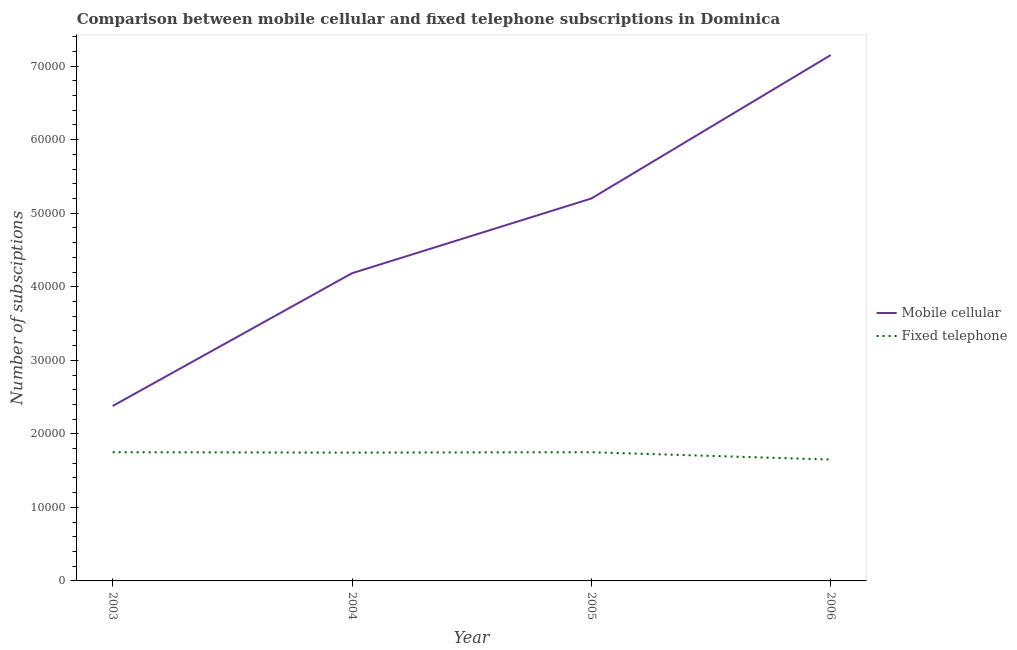What is the number of mobile cellular subscriptions in 2006?
Your answer should be compact. 7.15e+04. Across all years, what is the maximum number of mobile cellular subscriptions?
Keep it short and to the point. 7.15e+04. Across all years, what is the minimum number of fixed telephone subscriptions?
Your answer should be very brief. 1.65e+04. What is the total number of fixed telephone subscriptions in the graph?
Your answer should be very brief. 6.90e+04. What is the difference between the number of fixed telephone subscriptions in 2004 and that in 2005?
Your response must be concise. -50. What is the difference between the number of mobile cellular subscriptions in 2003 and the number of fixed telephone subscriptions in 2005?
Your answer should be very brief. 6286. What is the average number of mobile cellular subscriptions per year?
Offer a very short reply. 4.73e+04. In the year 2005, what is the difference between the number of mobile cellular subscriptions and number of fixed telephone subscriptions?
Provide a short and direct response. 3.45e+04. In how many years, is the number of fixed telephone subscriptions greater than 70000?
Offer a very short reply. 0. What is the difference between the highest and the second highest number of fixed telephone subscriptions?
Provide a succinct answer. 0. What is the difference between the highest and the lowest number of mobile cellular subscriptions?
Offer a very short reply. 4.77e+04. In how many years, is the number of mobile cellular subscriptions greater than the average number of mobile cellular subscriptions taken over all years?
Give a very brief answer. 2. Is the number of fixed telephone subscriptions strictly greater than the number of mobile cellular subscriptions over the years?
Keep it short and to the point. No. How many lines are there?
Your response must be concise. 2. Does the graph contain any zero values?
Ensure brevity in your answer.  No. Does the graph contain grids?
Your answer should be compact. No. How many legend labels are there?
Provide a short and direct response. 2. How are the legend labels stacked?
Offer a terse response. Vertical. What is the title of the graph?
Your answer should be very brief. Comparison between mobile cellular and fixed telephone subscriptions in Dominica. What is the label or title of the Y-axis?
Ensure brevity in your answer.  Number of subsciptions. What is the Number of subsciptions of Mobile cellular in 2003?
Your answer should be very brief. 2.38e+04. What is the Number of subsciptions of Fixed telephone in 2003?
Offer a terse response. 1.75e+04. What is the Number of subsciptions of Mobile cellular in 2004?
Make the answer very short. 4.18e+04. What is the Number of subsciptions of Fixed telephone in 2004?
Give a very brief answer. 1.74e+04. What is the Number of subsciptions in Mobile cellular in 2005?
Your response must be concise. 5.20e+04. What is the Number of subsciptions in Fixed telephone in 2005?
Your response must be concise. 1.75e+04. What is the Number of subsciptions of Mobile cellular in 2006?
Offer a very short reply. 7.15e+04. What is the Number of subsciptions in Fixed telephone in 2006?
Offer a very short reply. 1.65e+04. Across all years, what is the maximum Number of subsciptions of Mobile cellular?
Provide a short and direct response. 7.15e+04. Across all years, what is the maximum Number of subsciptions in Fixed telephone?
Your response must be concise. 1.75e+04. Across all years, what is the minimum Number of subsciptions of Mobile cellular?
Your response must be concise. 2.38e+04. Across all years, what is the minimum Number of subsciptions of Fixed telephone?
Keep it short and to the point. 1.65e+04. What is the total Number of subsciptions of Mobile cellular in the graph?
Ensure brevity in your answer.  1.89e+05. What is the total Number of subsciptions of Fixed telephone in the graph?
Give a very brief answer. 6.90e+04. What is the difference between the Number of subsciptions in Mobile cellular in 2003 and that in 2004?
Ensure brevity in your answer.  -1.81e+04. What is the difference between the Number of subsciptions in Fixed telephone in 2003 and that in 2004?
Your response must be concise. 50. What is the difference between the Number of subsciptions in Mobile cellular in 2003 and that in 2005?
Make the answer very short. -2.82e+04. What is the difference between the Number of subsciptions of Mobile cellular in 2003 and that in 2006?
Keep it short and to the point. -4.77e+04. What is the difference between the Number of subsciptions of Fixed telephone in 2003 and that in 2006?
Give a very brief answer. 1000. What is the difference between the Number of subsciptions of Mobile cellular in 2004 and that in 2005?
Offer a very short reply. -1.02e+04. What is the difference between the Number of subsciptions in Mobile cellular in 2004 and that in 2006?
Provide a succinct answer. -2.97e+04. What is the difference between the Number of subsciptions in Fixed telephone in 2004 and that in 2006?
Give a very brief answer. 950. What is the difference between the Number of subsciptions of Mobile cellular in 2005 and that in 2006?
Offer a very short reply. -1.95e+04. What is the difference between the Number of subsciptions of Mobile cellular in 2003 and the Number of subsciptions of Fixed telephone in 2004?
Provide a short and direct response. 6336. What is the difference between the Number of subsciptions in Mobile cellular in 2003 and the Number of subsciptions in Fixed telephone in 2005?
Ensure brevity in your answer.  6286. What is the difference between the Number of subsciptions of Mobile cellular in 2003 and the Number of subsciptions of Fixed telephone in 2006?
Ensure brevity in your answer.  7286. What is the difference between the Number of subsciptions of Mobile cellular in 2004 and the Number of subsciptions of Fixed telephone in 2005?
Make the answer very short. 2.43e+04. What is the difference between the Number of subsciptions of Mobile cellular in 2004 and the Number of subsciptions of Fixed telephone in 2006?
Keep it short and to the point. 2.53e+04. What is the difference between the Number of subsciptions of Mobile cellular in 2005 and the Number of subsciptions of Fixed telephone in 2006?
Your answer should be compact. 3.55e+04. What is the average Number of subsciptions in Mobile cellular per year?
Offer a very short reply. 4.73e+04. What is the average Number of subsciptions of Fixed telephone per year?
Offer a very short reply. 1.72e+04. In the year 2003, what is the difference between the Number of subsciptions of Mobile cellular and Number of subsciptions of Fixed telephone?
Your response must be concise. 6286. In the year 2004, what is the difference between the Number of subsciptions in Mobile cellular and Number of subsciptions in Fixed telephone?
Offer a terse response. 2.44e+04. In the year 2005, what is the difference between the Number of subsciptions of Mobile cellular and Number of subsciptions of Fixed telephone?
Ensure brevity in your answer.  3.45e+04. In the year 2006, what is the difference between the Number of subsciptions in Mobile cellular and Number of subsciptions in Fixed telephone?
Keep it short and to the point. 5.50e+04. What is the ratio of the Number of subsciptions in Mobile cellular in 2003 to that in 2004?
Your answer should be compact. 0.57. What is the ratio of the Number of subsciptions in Fixed telephone in 2003 to that in 2004?
Provide a short and direct response. 1. What is the ratio of the Number of subsciptions in Mobile cellular in 2003 to that in 2005?
Provide a succinct answer. 0.46. What is the ratio of the Number of subsciptions in Mobile cellular in 2003 to that in 2006?
Provide a succinct answer. 0.33. What is the ratio of the Number of subsciptions of Fixed telephone in 2003 to that in 2006?
Ensure brevity in your answer.  1.06. What is the ratio of the Number of subsciptions of Mobile cellular in 2004 to that in 2005?
Ensure brevity in your answer.  0.8. What is the ratio of the Number of subsciptions of Fixed telephone in 2004 to that in 2005?
Ensure brevity in your answer.  1. What is the ratio of the Number of subsciptions of Mobile cellular in 2004 to that in 2006?
Provide a short and direct response. 0.59. What is the ratio of the Number of subsciptions of Fixed telephone in 2004 to that in 2006?
Offer a terse response. 1.06. What is the ratio of the Number of subsciptions of Mobile cellular in 2005 to that in 2006?
Keep it short and to the point. 0.73. What is the ratio of the Number of subsciptions in Fixed telephone in 2005 to that in 2006?
Offer a terse response. 1.06. What is the difference between the highest and the second highest Number of subsciptions in Mobile cellular?
Provide a succinct answer. 1.95e+04. What is the difference between the highest and the second highest Number of subsciptions in Fixed telephone?
Offer a terse response. 0. What is the difference between the highest and the lowest Number of subsciptions of Mobile cellular?
Offer a very short reply. 4.77e+04. What is the difference between the highest and the lowest Number of subsciptions of Fixed telephone?
Keep it short and to the point. 1000. 